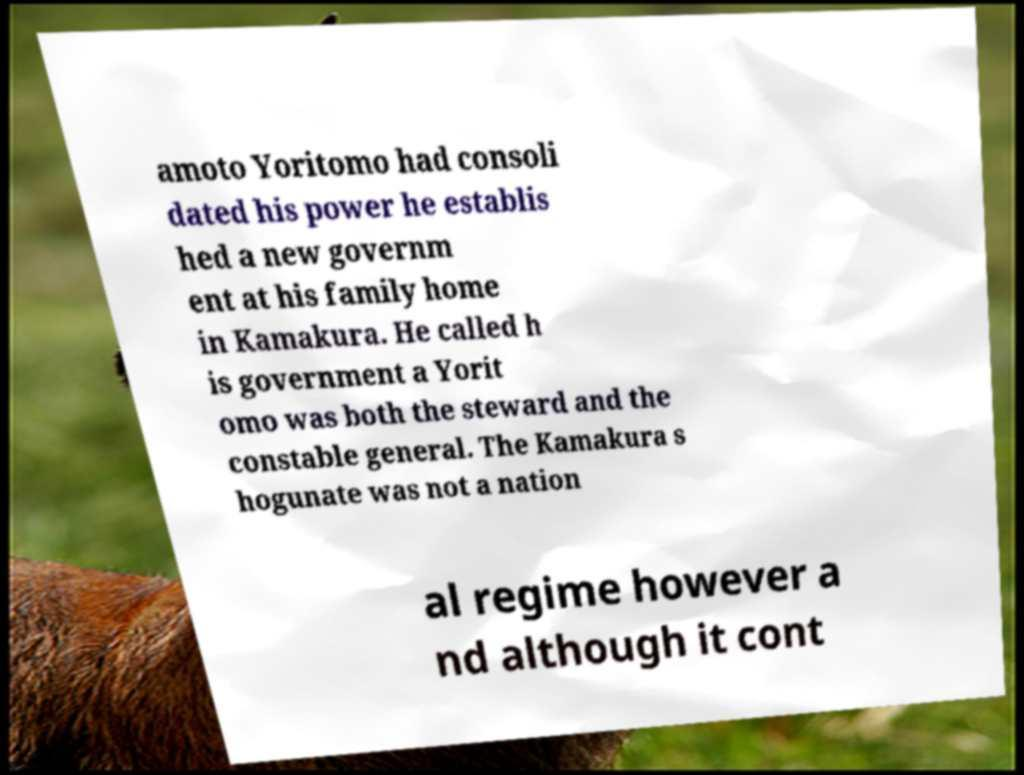What messages or text are displayed in this image? I need them in a readable, typed format. amoto Yoritomo had consoli dated his power he establis hed a new governm ent at his family home in Kamakura. He called h is government a Yorit omo was both the steward and the constable general. The Kamakura s hogunate was not a nation al regime however a nd although it cont 